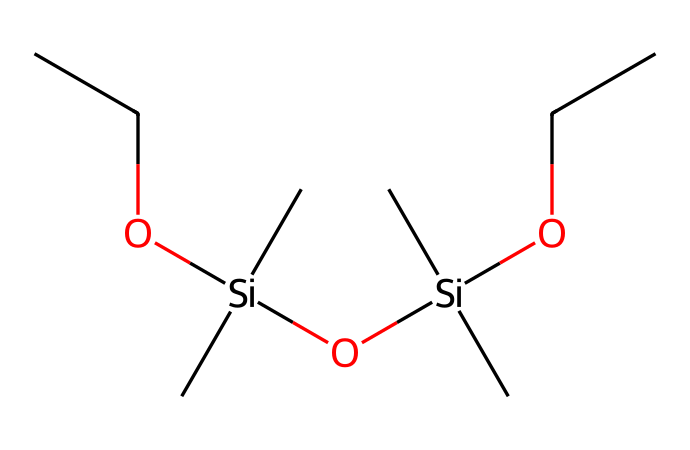What is the main functional group present in this chemical? The chemical structure shows multiple siloxane (Si-O) linkages and ether (C-O) linkages, indicating the presence of both siloxane and ether functional groups.
Answer: siloxane ether How many silicon atoms are in the chemical structure? By analyzing the structure, we can count two silicon atoms present in the SMILES representation.
Answer: two What type of bonding characterizes the connection between the silicon and oxygen atoms in the structure? The bonds between silicon and oxygen in this structure are covalent, typical for the siloxane linkages present in ethers.
Answer: covalent What is the ratio of carbon atoms to oxygen atoms in this chemical? In the provided SMILES, there are 10 carbon atoms and 4 oxygen atoms, leading to a ratio of 10:4, which simplifies to 5:2.
Answer: five to two Which part of the molecule contributes to its flexibility? The siloxane linkages (Si-O bonds) provide flexibility due to their ability to rotate freely, unlike traditional carbon-oxygen ether bonds.
Answer: siloxane linkages What is the total number of ether linkages in this chemical structure? By inspecting the SMILES representation, we can determine there are two ether linkages present in the structure.
Answer: two 